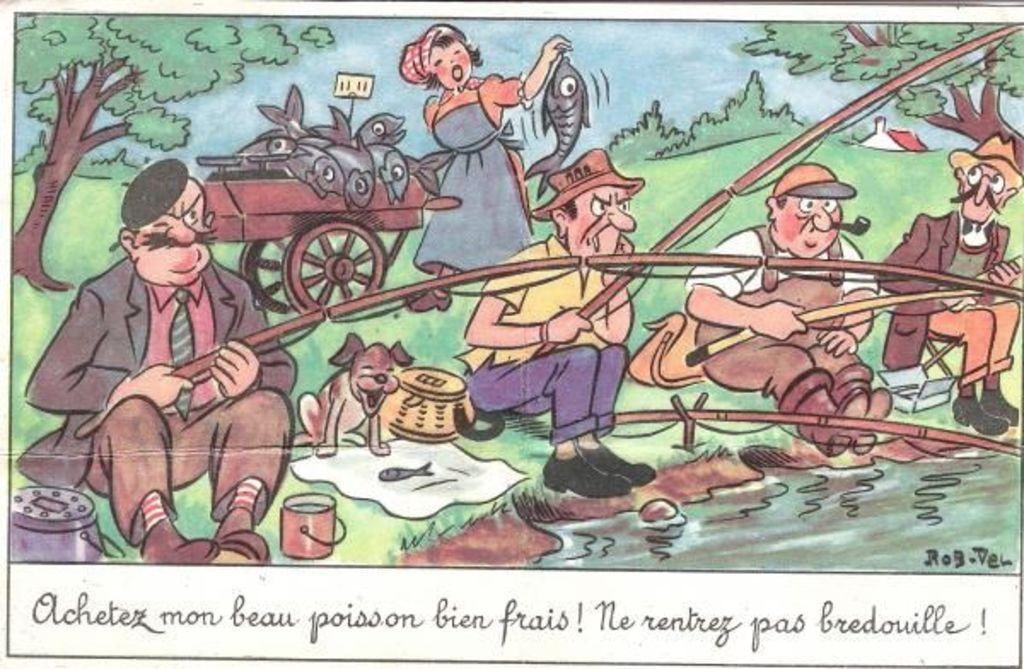Could you give a brief overview of what you see in this image? In this image I can see the depiction picture, in which I can see 4 men who are holding fishing rods and I can see a women holding a fish and I see a cart on which there are few more fishes. I can also see the water, a dog and other few things. In the background I can see the trees and plants. On the bottom of this picture I can see something is written. 